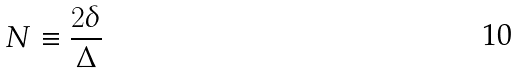Convert formula to latex. <formula><loc_0><loc_0><loc_500><loc_500>N \equiv \frac { 2 \delta } { \Delta }</formula> 